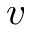Convert formula to latex. <formula><loc_0><loc_0><loc_500><loc_500>v</formula> 